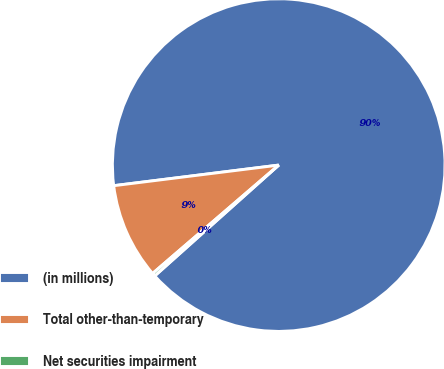Convert chart. <chart><loc_0><loc_0><loc_500><loc_500><pie_chart><fcel>(in millions)<fcel>Total other-than-temporary<fcel>Net securities impairment<nl><fcel>90.37%<fcel>9.32%<fcel>0.31%<nl></chart> 